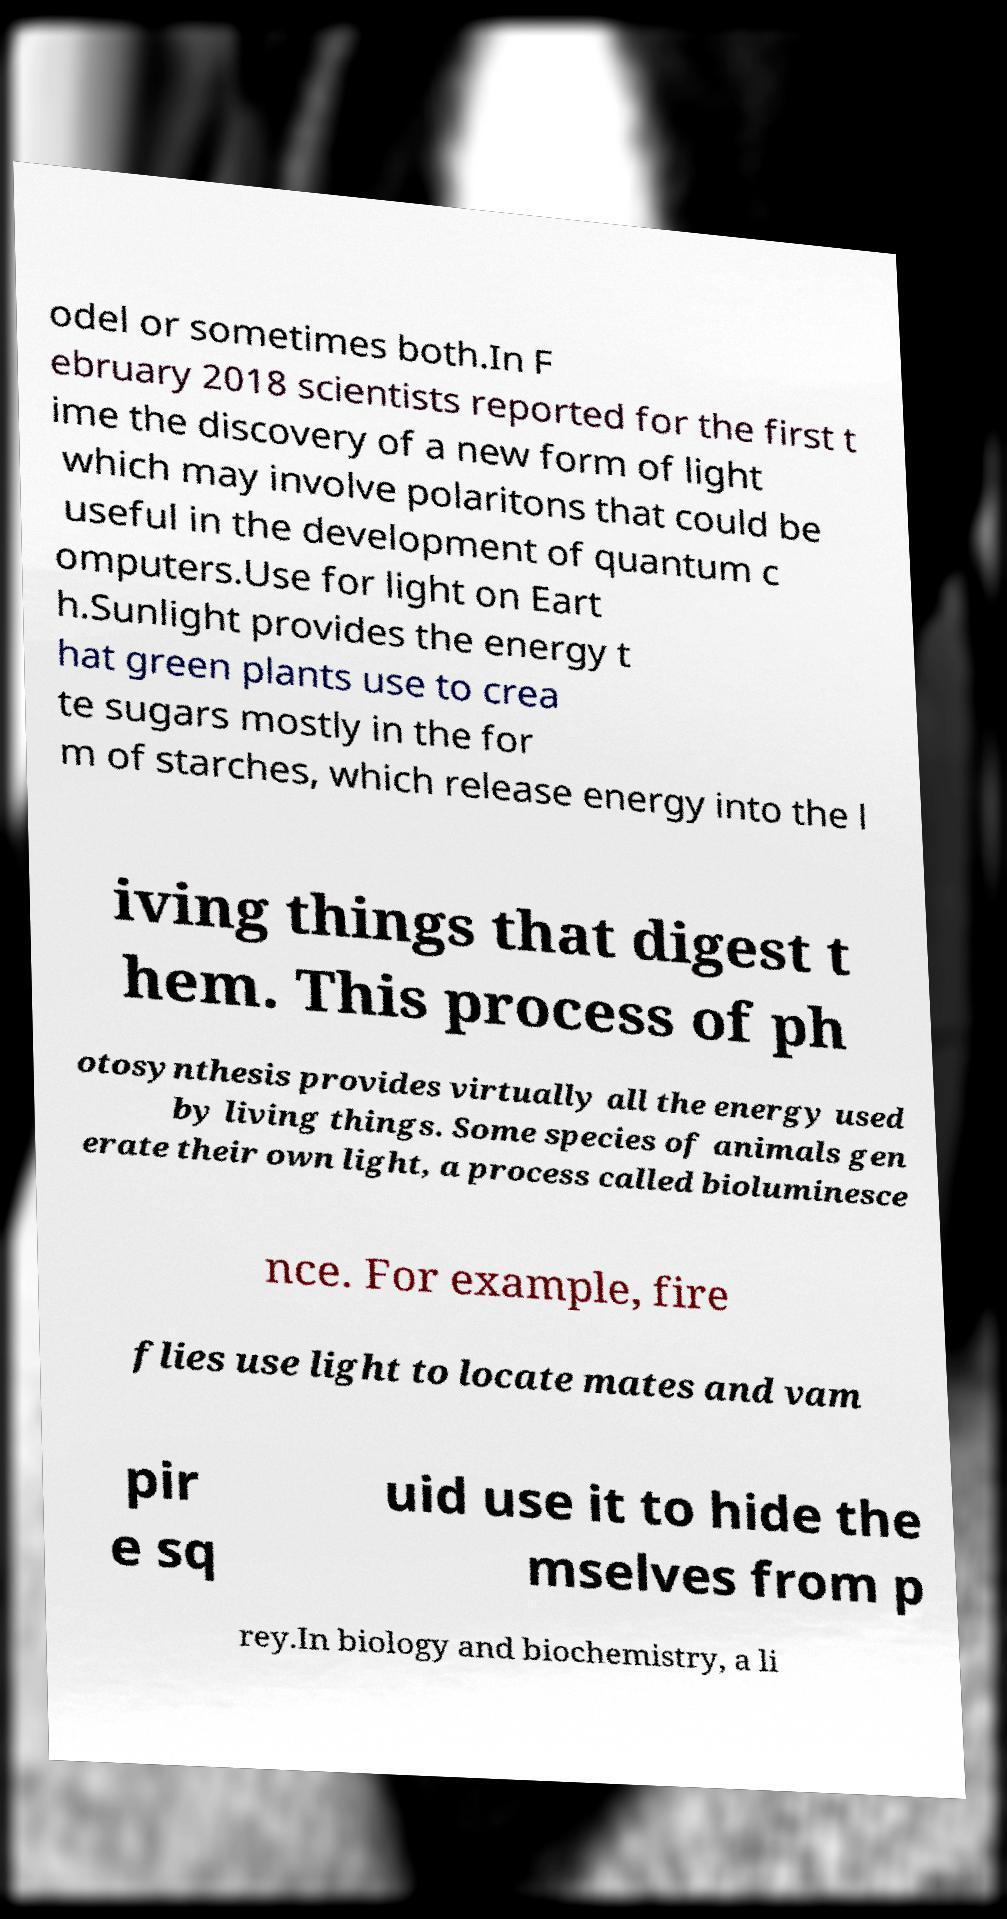There's text embedded in this image that I need extracted. Can you transcribe it verbatim? odel or sometimes both.In F ebruary 2018 scientists reported for the first t ime the discovery of a new form of light which may involve polaritons that could be useful in the development of quantum c omputers.Use for light on Eart h.Sunlight provides the energy t hat green plants use to crea te sugars mostly in the for m of starches, which release energy into the l iving things that digest t hem. This process of ph otosynthesis provides virtually all the energy used by living things. Some species of animals gen erate their own light, a process called bioluminesce nce. For example, fire flies use light to locate mates and vam pir e sq uid use it to hide the mselves from p rey.In biology and biochemistry, a li 